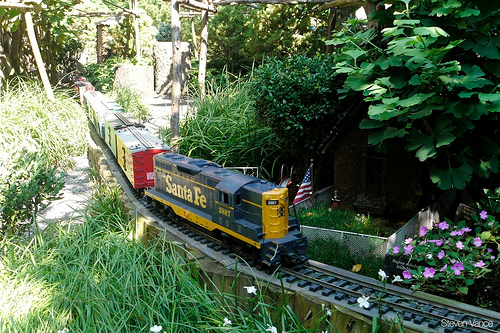Please provide the bounding box coordinate of the region this sentence describes: flowers are pink. The pink flowers can be found within the bounding box coordinates [0.77, 0.58, 1.0, 0.74]. 